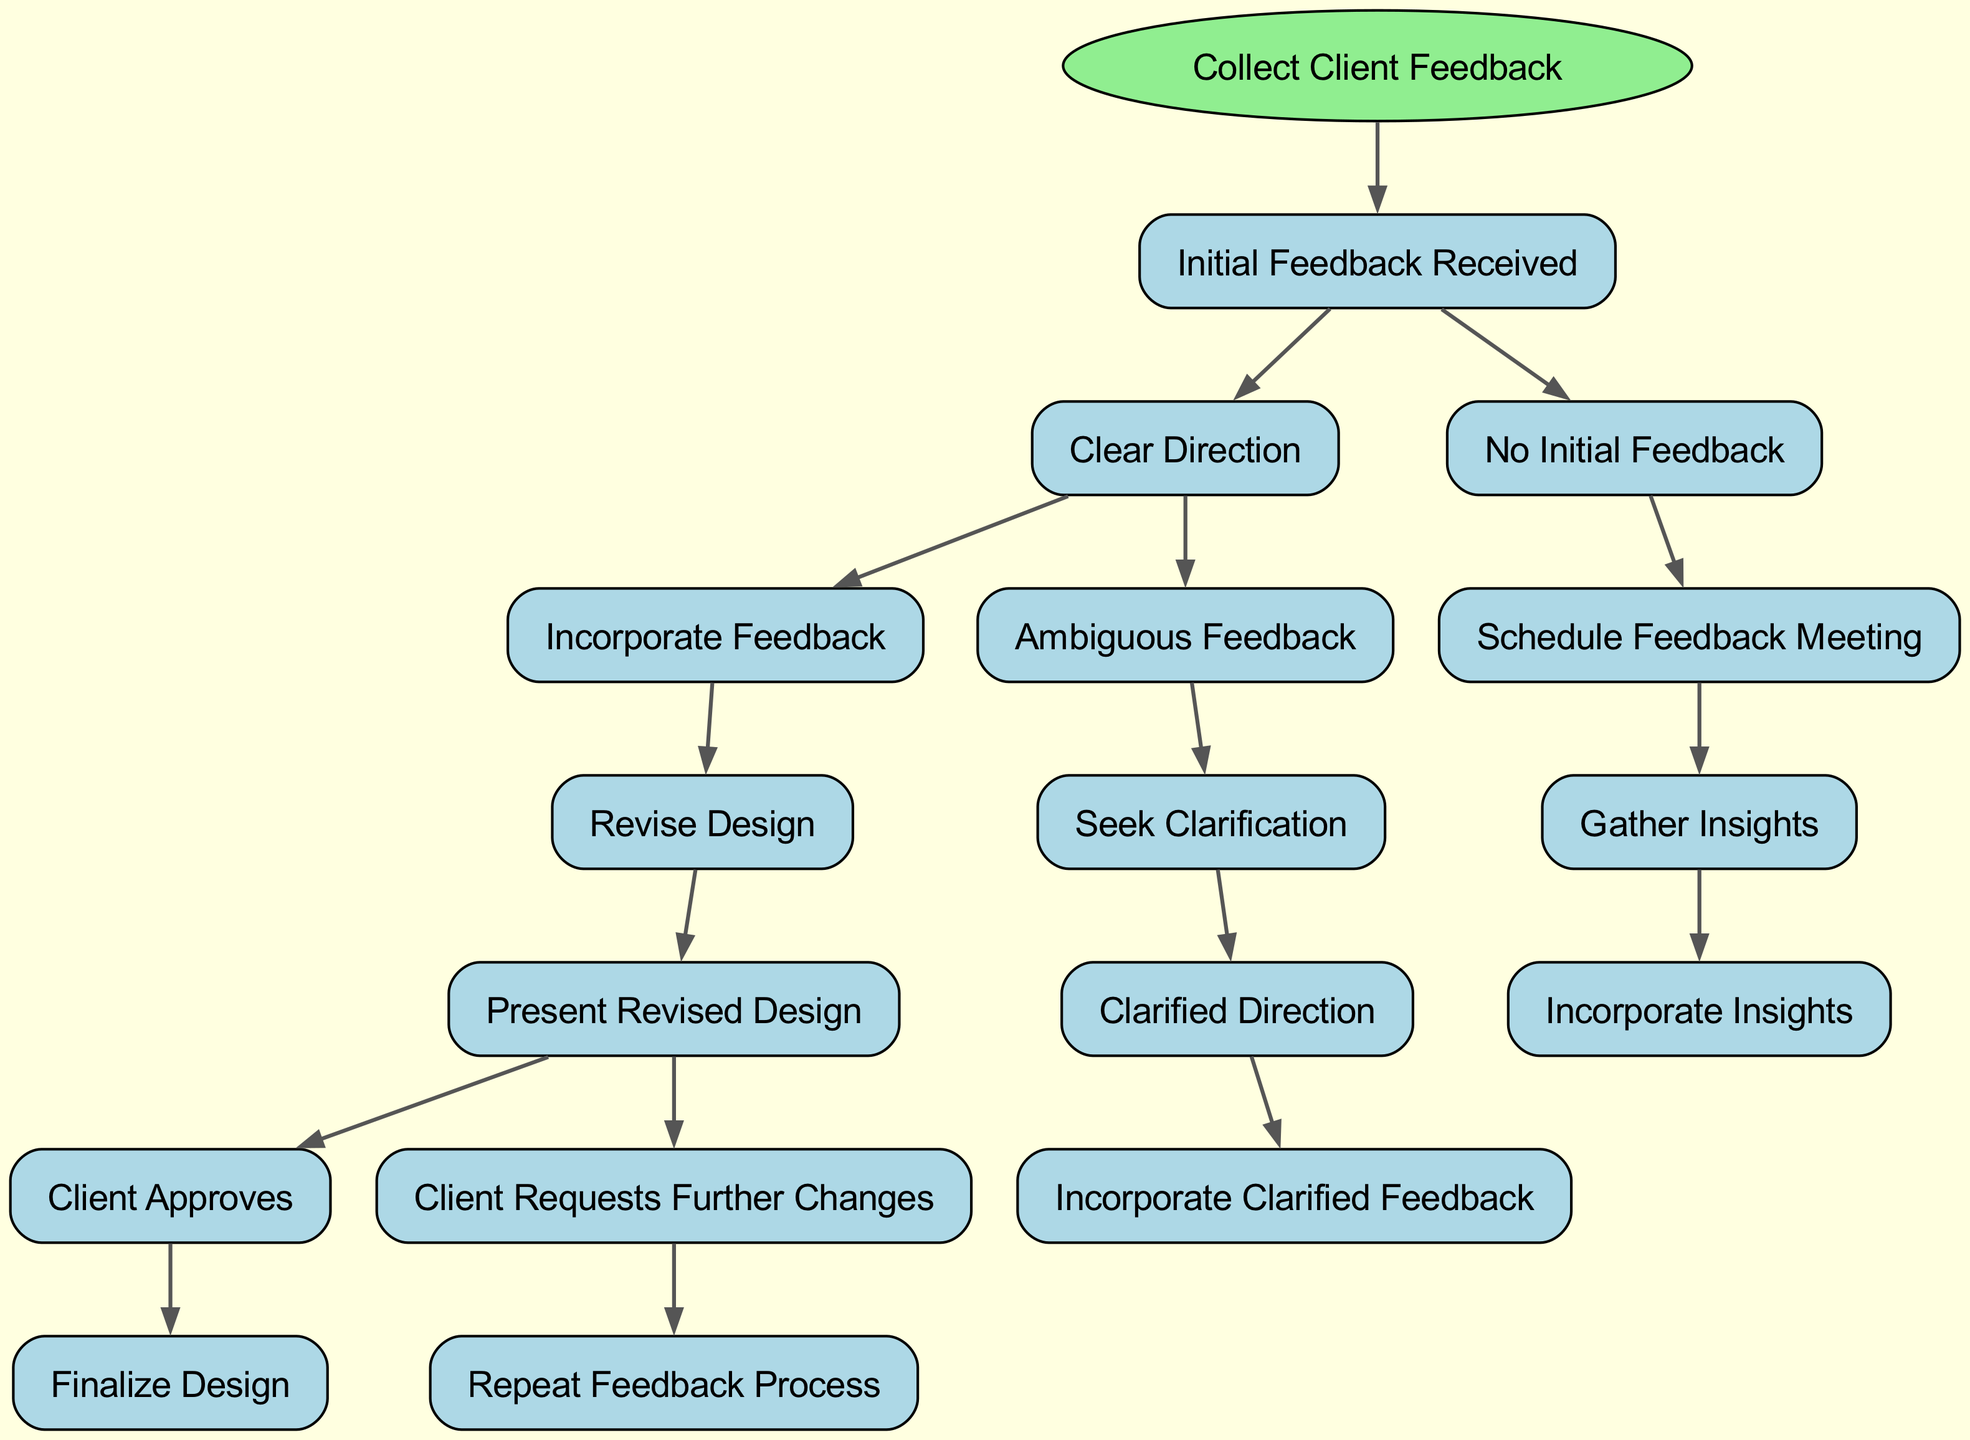What is the first step in the decision tree? The first step in the decision tree is labeled "Collect Client Feedback." This is indicated as the root node from which all branches originate.
Answer: Collect Client Feedback How many branches are there under "Initial Feedback Received"? Under the node "Initial Feedback Received," there are two branches, namely "Clear Direction" and "No Initial Feedback." This is determined by looking at the direct subdivisions of the initial feedback node.
Answer: 2 What happens if the client gives ambiguous feedback? If the client provides ambiguous feedback, the next step is to "Seek Clarification," which is indicated as the response to ambiguous feedback in the diagram.
Answer: Seek Clarification How many final outcomes can be reached in this decision tree? There are three final outcomes: "Finalize Design," "Repeat Feedback Process," and "Incorporate Clarified Feedback." By tracing through the branches, we identify these terminal nodes without further subdivisions.
Answer: 3 What node follows "Incorporate Feedback"? The node that follows "Incorporate Feedback" is "Revise Design." This conclusion is reached by examining the sequence of the branches from the feedback incorporation step.
Answer: Revise Design What action occurs after "Present Revised Design" if the client requests further changes? If the client requests further changes after "Present Revised Design," the action that follows is to "Repeat Feedback Process." This is depicted in the diagram as an outcome of client dissatisfaction with the revised design.
Answer: Repeat Feedback Process Which node requires scheduling a meeting? The node that entails scheduling a meeting is "Schedule Feedback Meeting," which comes after the scenario where there is "No Initial Feedback." This node is specifically designed to solicit input from the client.
Answer: Schedule Feedback Meeting What do you do after receiving "Clarified Direction"? After receiving "Clarified Direction," the next step is to "Incorporate Clarified Feedback," as indicated in the diagram where this is the subsequent action following clarification.
Answer: Incorporate Clarified Feedback 